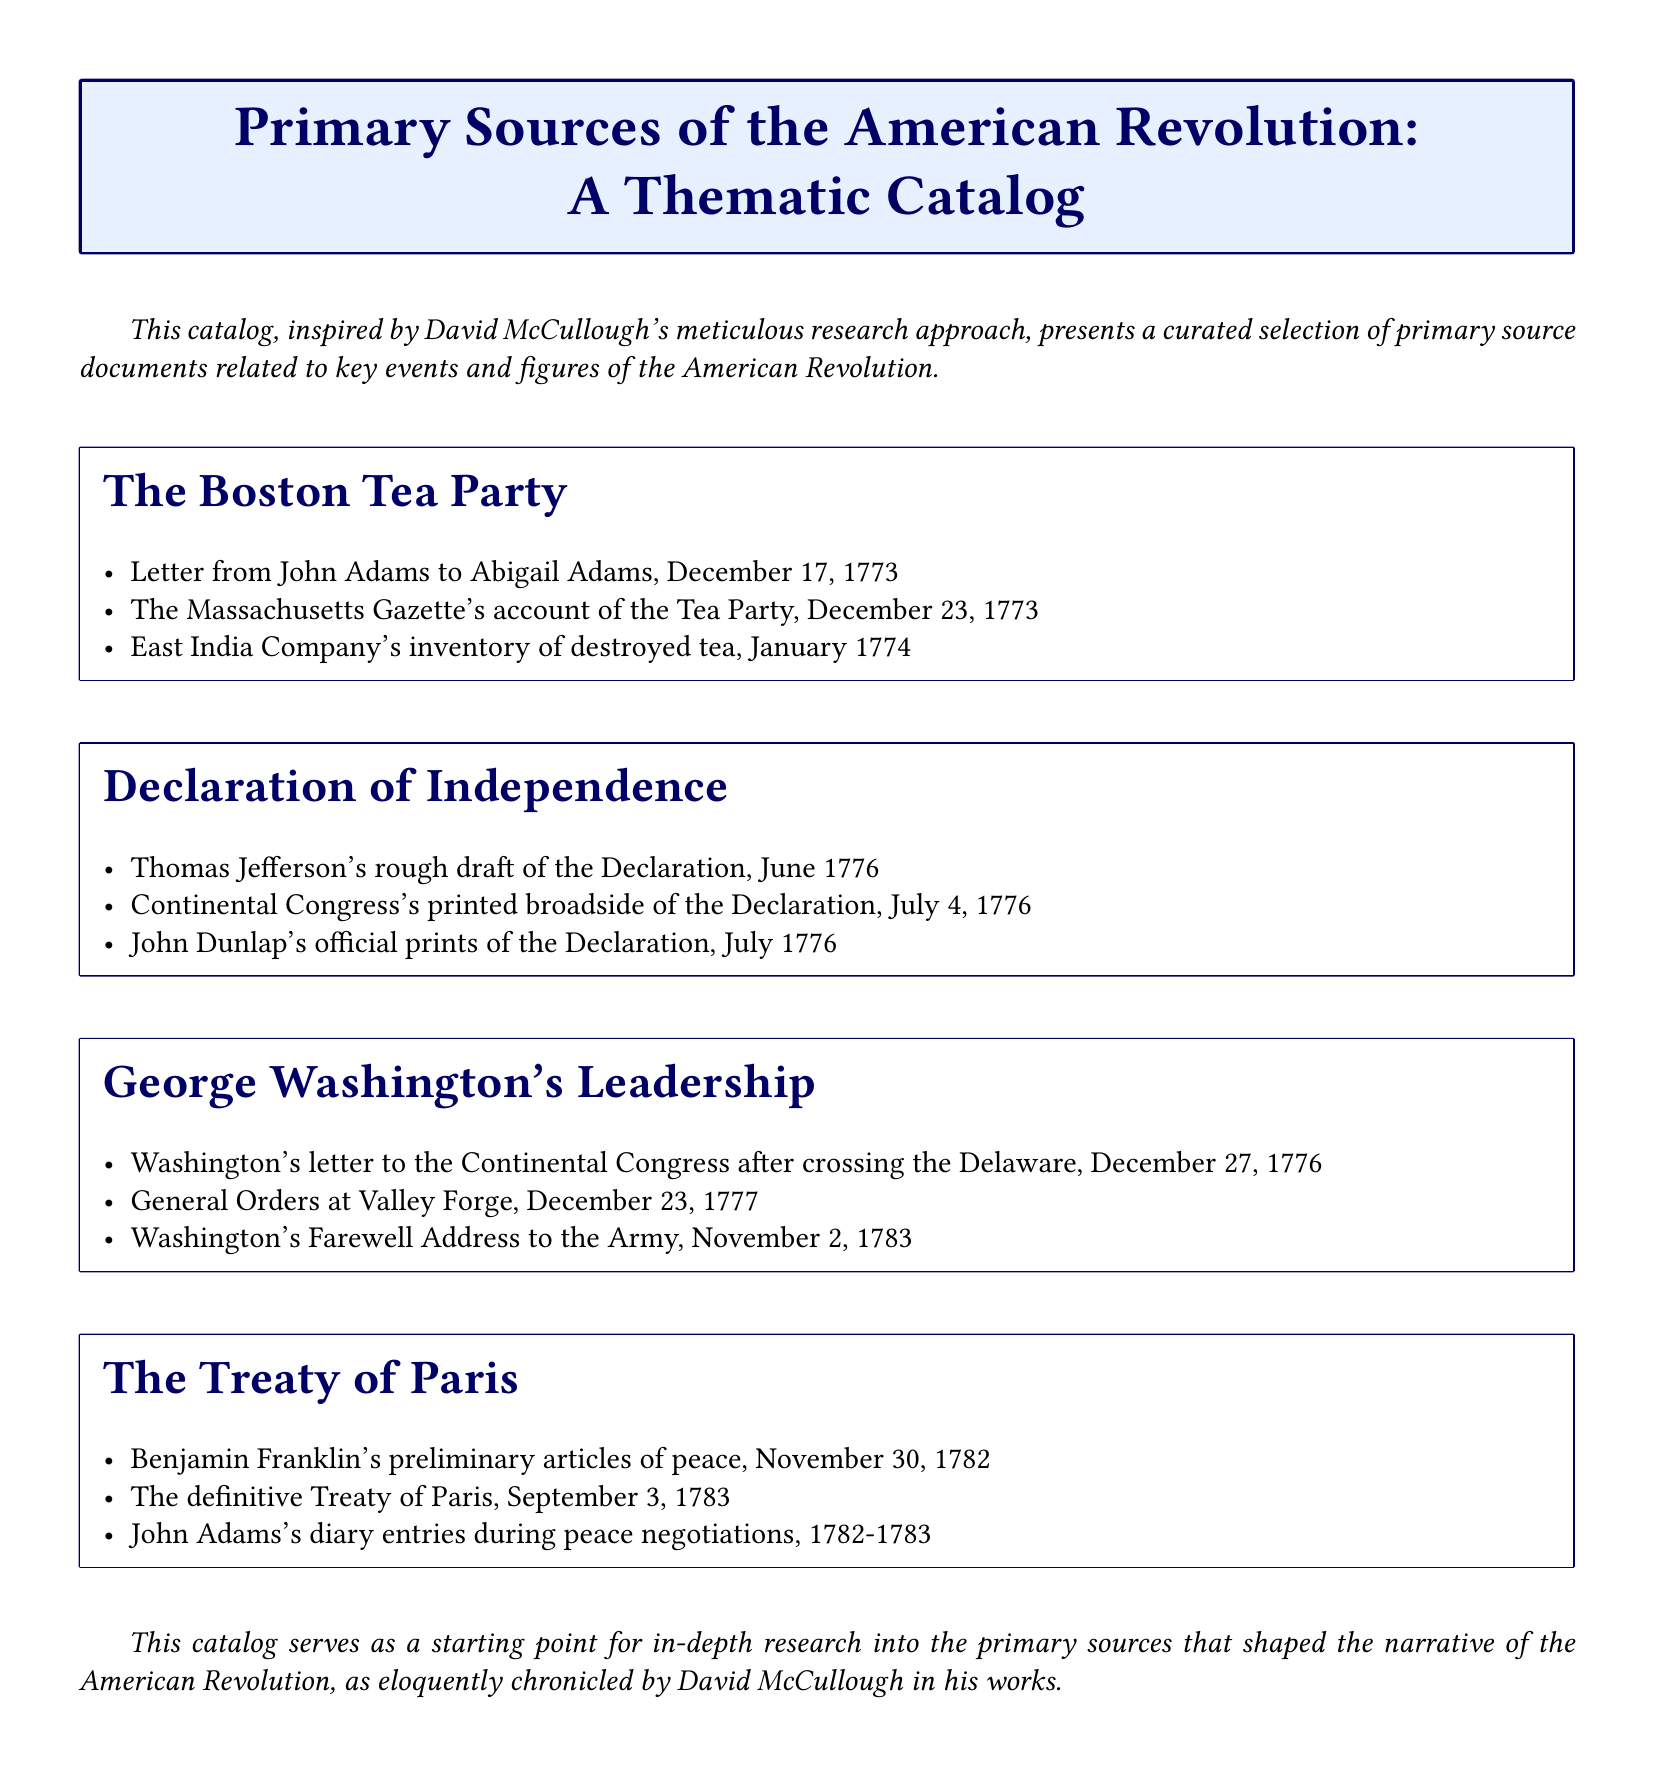What is the first document listed under the Boston Tea Party? The first document under the Boston Tea Party section is a letter from John Adams to Abigail Adams.
Answer: Letter from John Adams to Abigail Adams What is the date of the Continental Congress's printed broadside of the Declaration? The document is dated July 4, 1776, which is clearly stated in the catalog.
Answer: July 4, 1776 Which event does the second section of the catalog focus on? The second section of the catalog focuses on the Declaration of Independence, as indicated by the section title.
Answer: Declaration of Independence How many documents are listed under George Washington's Leadership? There are three documents listed under George Washington's Leadership in the catalog.
Answer: Three What document did Benjamin Franklin prepare before the Treaty of Paris? The document prepared by Benjamin Franklin is the preliminary articles of peace, dated November 30, 1782.
Answer: Preliminary articles of peace Which year marks the end of George Washington's Farewell Address to the Army? The year mentioned for Washington's Farewell Address to the Army is 1783, signaling the end of the address.
Answer: 1783 What was the first primary source documented for the Treaty of Paris section? The first primary source documented is Benjamin Franklin's preliminary articles of peace.
Answer: Benjamin Franklin's preliminary articles of peace How did the catalog format the sections? The sections are formatted using tcolorbox with a color scheme and stylized titles.
Answer: Tcolorbox 